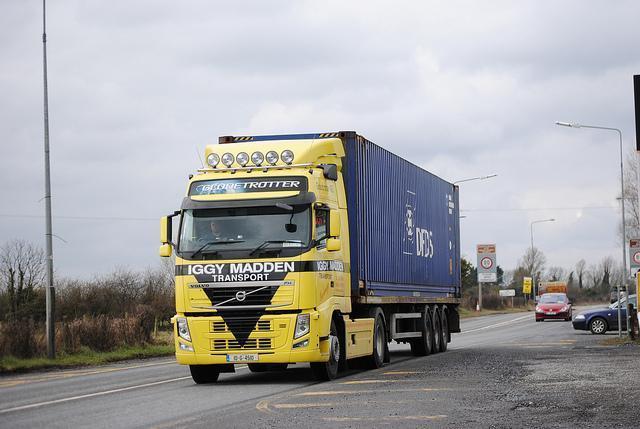How many trucks are in the photo?
Give a very brief answer. 1. 